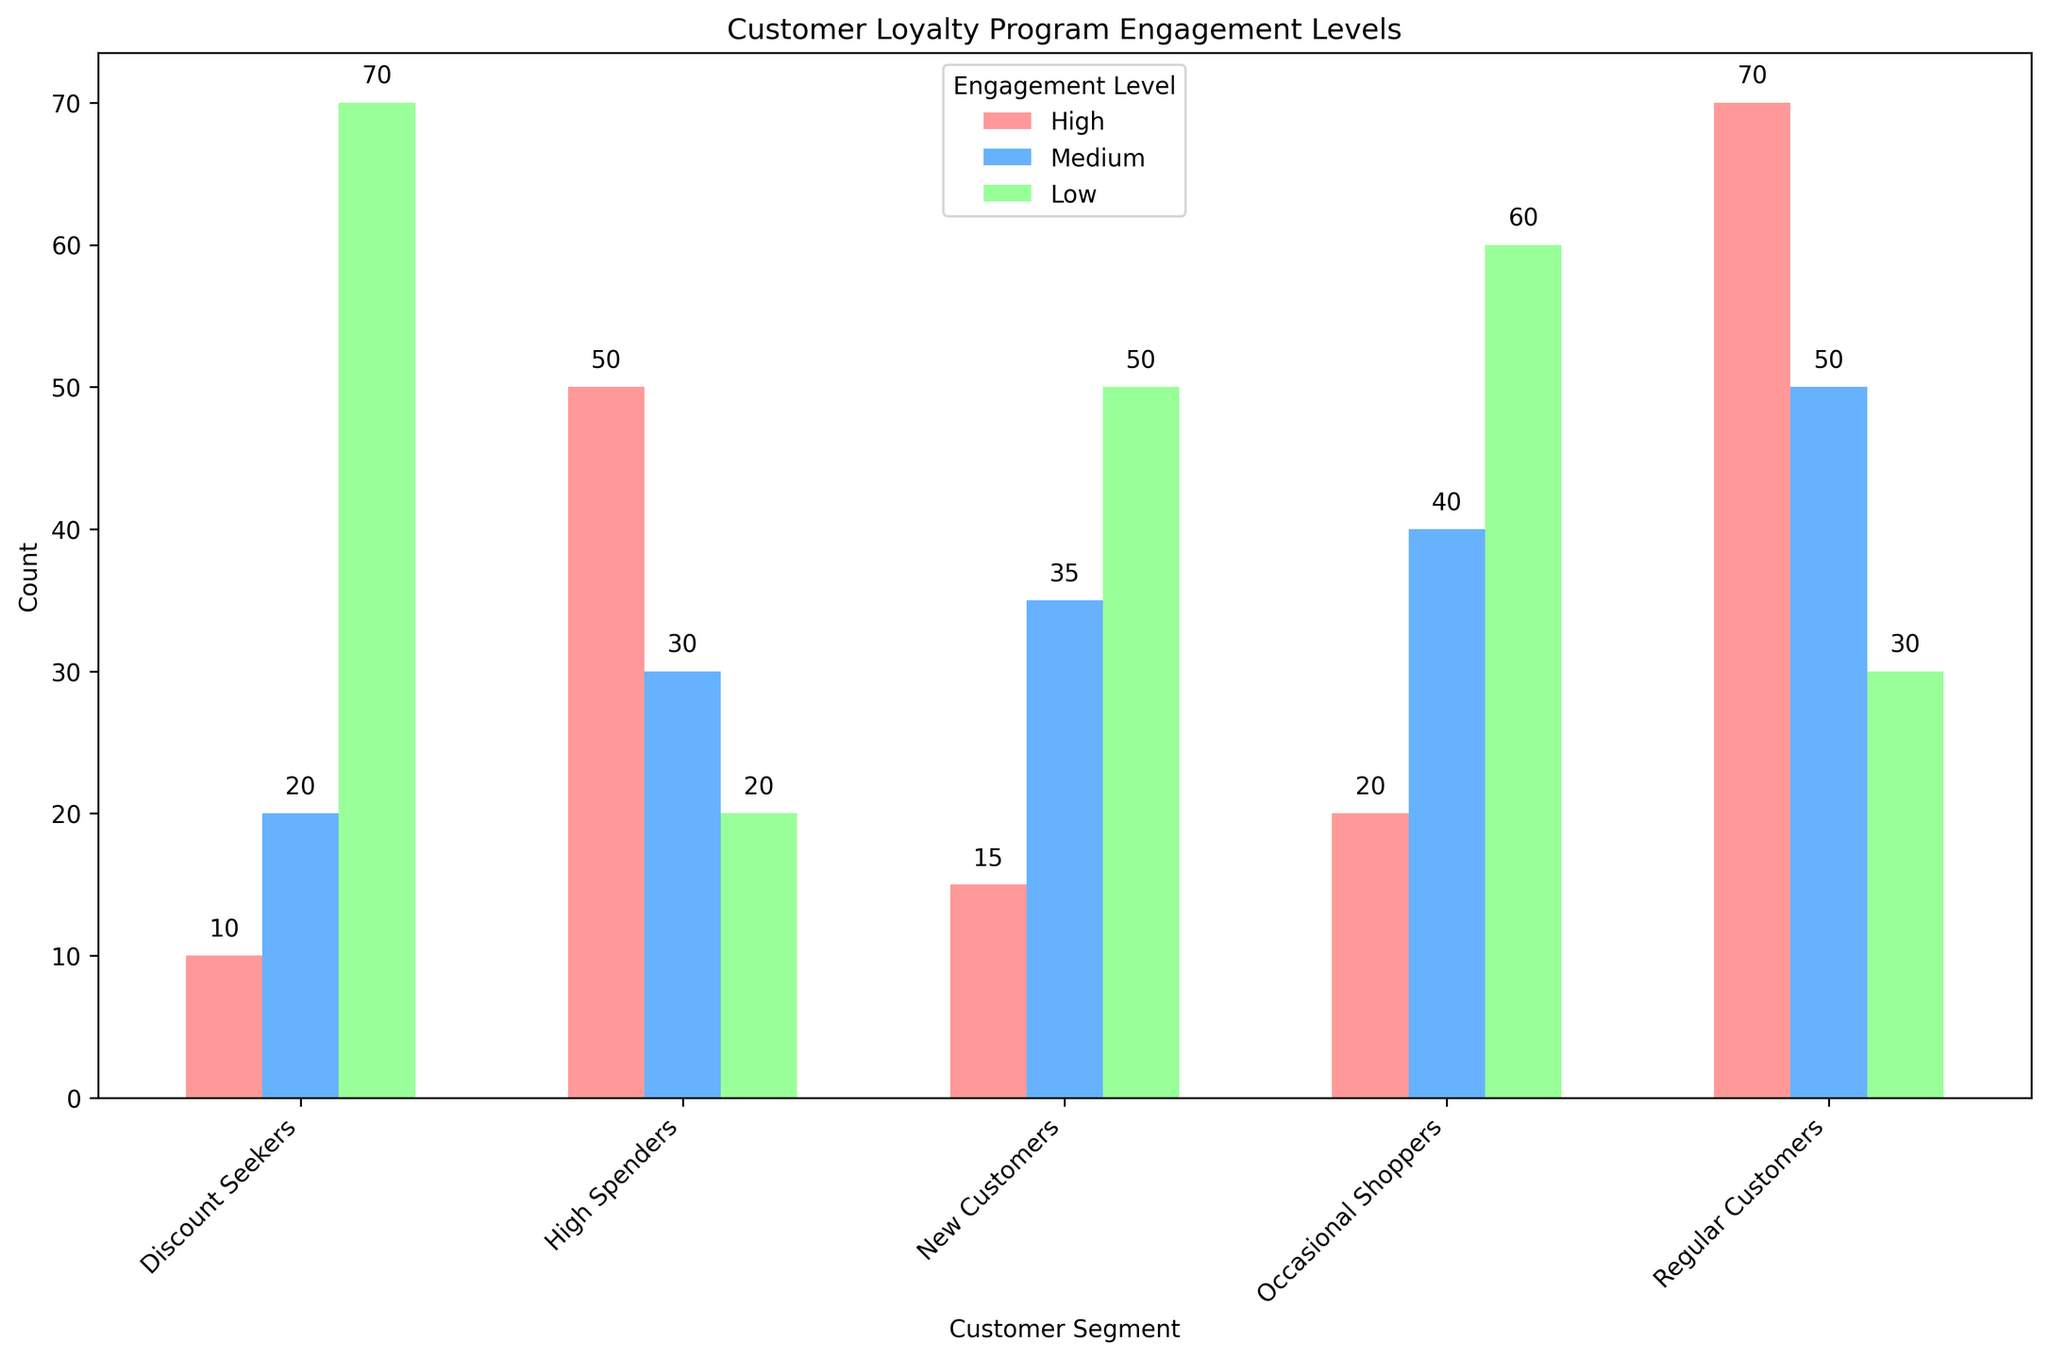Which customer segment has the highest level of high engagement in the loyalty program? Look at the height of the red bars across the segments. The Regular Customers segment has the highest red bar.
Answer: Regular Customers What is the total number of high engagement customers across all segments? Sum the heights of the red bars: 50 (High Spenders) + 20 (Occasional Shoppers) + 70 (Regular Customers) + 10 (Discount Seekers) + 15 (New Customers) = 165
Answer: 165 Which customer segment has the lowest count of medium engagement? Compare the heights of the blue bars across the segments. The Discount Seekers segment has the shortest blue bar.
Answer: Discount Seekers What is the difference in low engagement levels between Discount Seekers and High Spenders? Subtract the height of the green bar for High Spenders from that of Discount Seekers: 70 (Discount Seekers) - 20 (High Spenders) = 50
Answer: 50 In which segment is the medium engagement level higher than the high engagement level, but lower than the low engagement level? Check the segments where the blue bars are taller than the red bars but shorter than the green bars. The Occasional Shoppers and New Customers segments fit this description.
Answer: Occasional Shoppers, New Customers Which customer segment shows the smallest overall engagement in high and medium levels combined? Sum the heights of the red and blue bars, and find the smallest sum: High Spenders (50+30=80), Occasional Shoppers (20+40=60), Regular Customers (70+50=120), Discount Seekers (10+20=30), and New Customers (15+35=50). The smallest sum is for Discount Seekers.
Answer: Discount Seekers Among Regular Customers, what is the ratio of high to low engagement counts? Divide the height of the red bar by the height of the green bar for Regular Customers: 70 (High) / 30 (Low) = 2.33
Answer: 2.33 How many more customers are in the low engagement level than in the medium engagement level for New Customers? Subtract the height of the blue bar from the height of the green bar for New Customers: 50 (Low) - 35 (Medium) = 15
Answer: 15 Which engagement level has the highest count across all customer segments? Compare the total heights of red, blue, and green bars. The green bars (Low) in total are the tallest.
Answer: Low 